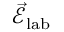Convert formula to latex. <formula><loc_0><loc_0><loc_500><loc_500>\vec { \mathcal { E } } _ { l a b }</formula> 